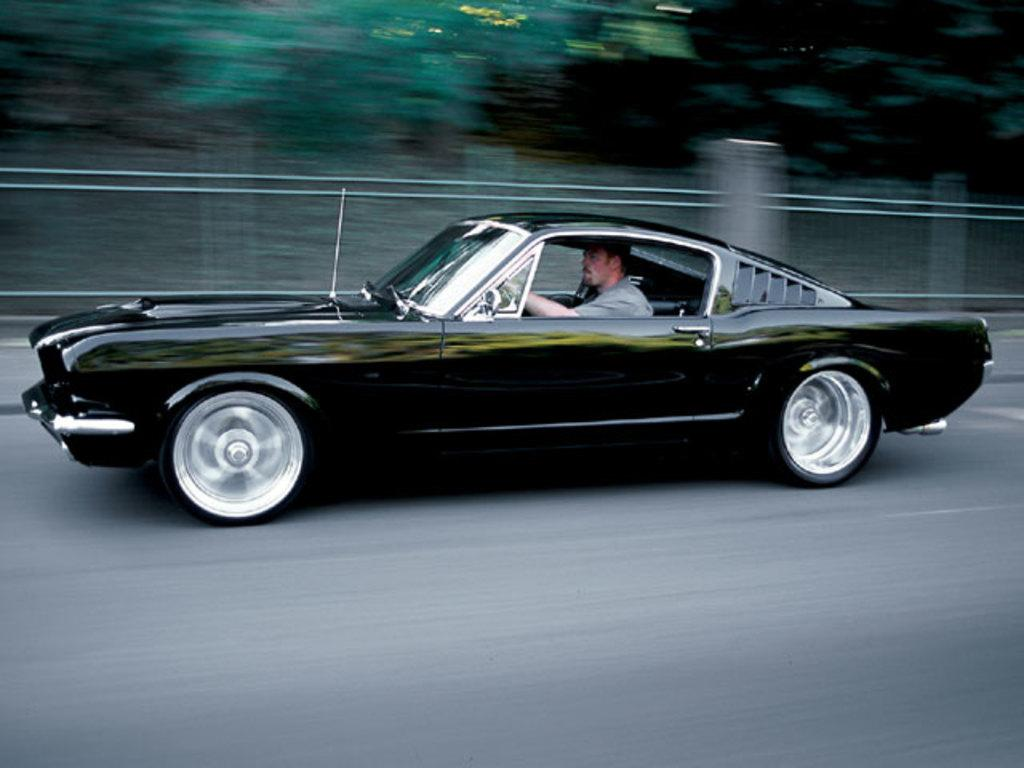What is the main subject of the image? The main subject of the image is a man riding a car. What color is the car in the image? The car is black. What can be seen in the background of the image? There are trees in the background of the image. What is the car doing in the image? The image is taken while the car is in motion. Where is the jail located in the image? There is no jail present in the image. What type of harbor can be seen in the image? There is no harbor present in the image. 